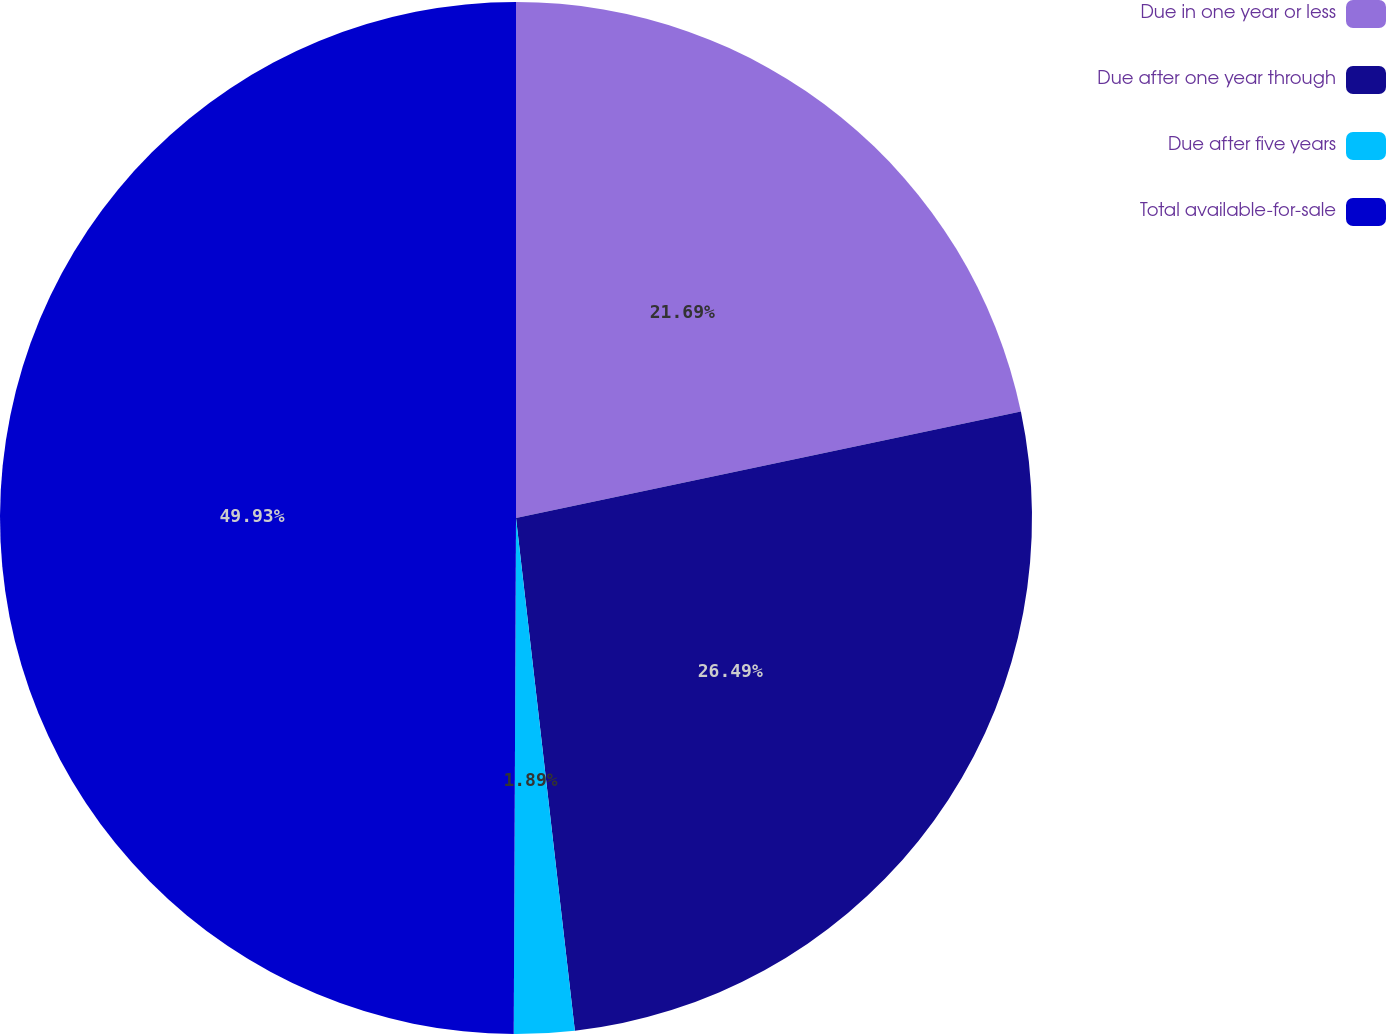Convert chart to OTSL. <chart><loc_0><loc_0><loc_500><loc_500><pie_chart><fcel>Due in one year or less<fcel>Due after one year through<fcel>Due after five years<fcel>Total available-for-sale<nl><fcel>21.69%<fcel>26.49%<fcel>1.89%<fcel>49.93%<nl></chart> 